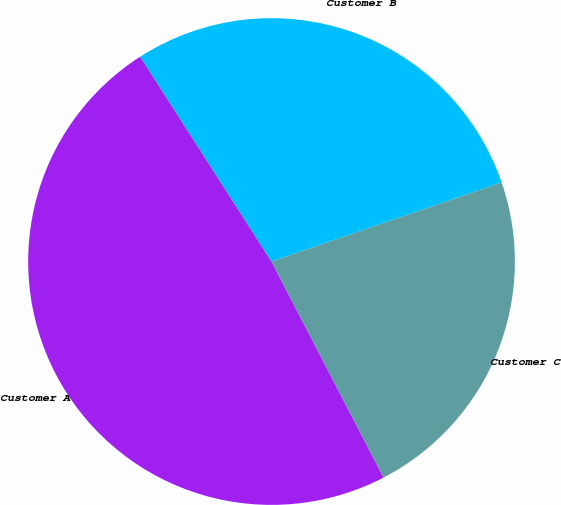<chart> <loc_0><loc_0><loc_500><loc_500><pie_chart><fcel>Customer A<fcel>Customer B<fcel>Customer C<nl><fcel>48.54%<fcel>28.8%<fcel>22.65%<nl></chart> 